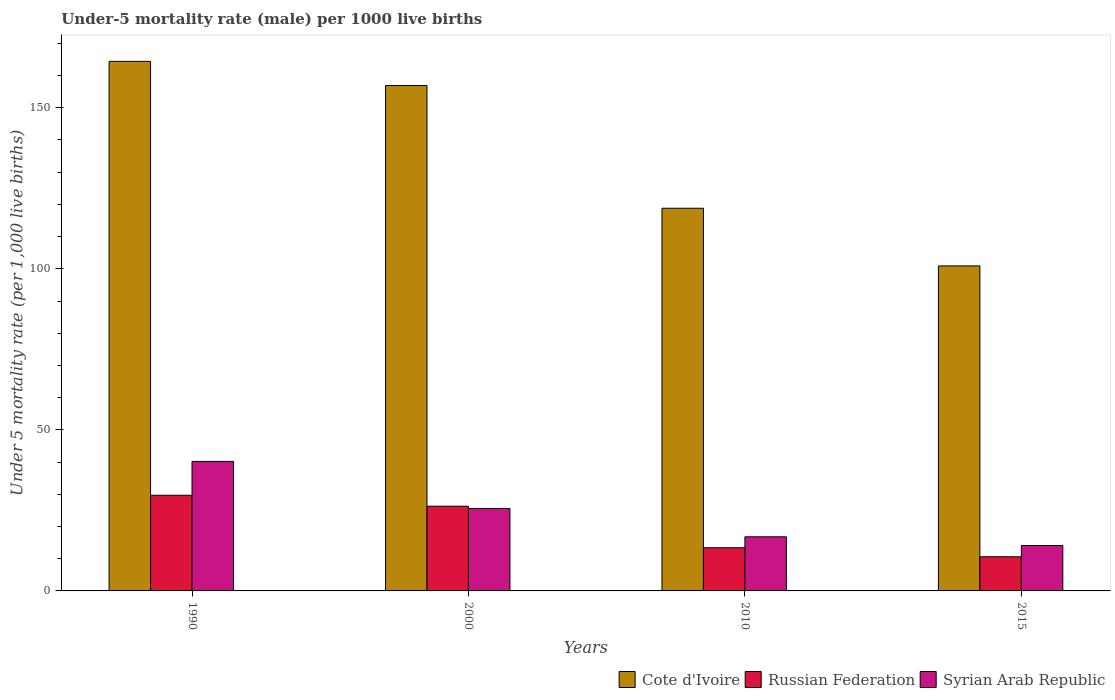How many different coloured bars are there?
Make the answer very short. 3. Are the number of bars per tick equal to the number of legend labels?
Your answer should be compact. Yes. How many bars are there on the 3rd tick from the left?
Keep it short and to the point. 3. What is the label of the 4th group of bars from the left?
Make the answer very short. 2015. In how many cases, is the number of bars for a given year not equal to the number of legend labels?
Offer a terse response. 0. What is the under-five mortality rate in Cote d'Ivoire in 2000?
Your answer should be compact. 156.9. Across all years, what is the maximum under-five mortality rate in Cote d'Ivoire?
Your response must be concise. 164.4. Across all years, what is the minimum under-five mortality rate in Russian Federation?
Your answer should be very brief. 10.6. In which year was the under-five mortality rate in Cote d'Ivoire minimum?
Your answer should be compact. 2015. What is the total under-five mortality rate in Cote d'Ivoire in the graph?
Keep it short and to the point. 541. What is the difference between the under-five mortality rate in Russian Federation in 2000 and that in 2015?
Keep it short and to the point. 15.7. What is the difference between the under-five mortality rate in Cote d'Ivoire in 2010 and the under-five mortality rate in Russian Federation in 2015?
Give a very brief answer. 108.2. What is the average under-five mortality rate in Syrian Arab Republic per year?
Keep it short and to the point. 24.18. In the year 2000, what is the difference between the under-five mortality rate in Russian Federation and under-five mortality rate in Cote d'Ivoire?
Your answer should be compact. -130.6. What is the ratio of the under-five mortality rate in Cote d'Ivoire in 1990 to that in 2015?
Your answer should be very brief. 1.63. Is the difference between the under-five mortality rate in Russian Federation in 2010 and 2015 greater than the difference between the under-five mortality rate in Cote d'Ivoire in 2010 and 2015?
Give a very brief answer. No. What is the difference between the highest and the second highest under-five mortality rate in Russian Federation?
Your answer should be compact. 3.4. In how many years, is the under-five mortality rate in Cote d'Ivoire greater than the average under-five mortality rate in Cote d'Ivoire taken over all years?
Your response must be concise. 2. Is the sum of the under-five mortality rate in Russian Federation in 1990 and 2015 greater than the maximum under-five mortality rate in Syrian Arab Republic across all years?
Your answer should be compact. Yes. What does the 1st bar from the left in 2000 represents?
Your answer should be very brief. Cote d'Ivoire. What does the 2nd bar from the right in 1990 represents?
Ensure brevity in your answer.  Russian Federation. Is it the case that in every year, the sum of the under-five mortality rate in Cote d'Ivoire and under-five mortality rate in Syrian Arab Republic is greater than the under-five mortality rate in Russian Federation?
Your answer should be compact. Yes. How many bars are there?
Provide a short and direct response. 12. Are all the bars in the graph horizontal?
Provide a short and direct response. No. How many years are there in the graph?
Your answer should be compact. 4. What is the difference between two consecutive major ticks on the Y-axis?
Your answer should be very brief. 50. Where does the legend appear in the graph?
Provide a succinct answer. Bottom right. What is the title of the graph?
Offer a very short reply. Under-5 mortality rate (male) per 1000 live births. What is the label or title of the X-axis?
Give a very brief answer. Years. What is the label or title of the Y-axis?
Your answer should be compact. Under 5 mortality rate (per 1,0 live births). What is the Under 5 mortality rate (per 1,000 live births) of Cote d'Ivoire in 1990?
Your response must be concise. 164.4. What is the Under 5 mortality rate (per 1,000 live births) in Russian Federation in 1990?
Provide a short and direct response. 29.7. What is the Under 5 mortality rate (per 1,000 live births) of Syrian Arab Republic in 1990?
Provide a short and direct response. 40.2. What is the Under 5 mortality rate (per 1,000 live births) in Cote d'Ivoire in 2000?
Provide a short and direct response. 156.9. What is the Under 5 mortality rate (per 1,000 live births) in Russian Federation in 2000?
Your response must be concise. 26.3. What is the Under 5 mortality rate (per 1,000 live births) of Syrian Arab Republic in 2000?
Give a very brief answer. 25.6. What is the Under 5 mortality rate (per 1,000 live births) of Cote d'Ivoire in 2010?
Ensure brevity in your answer.  118.8. What is the Under 5 mortality rate (per 1,000 live births) in Syrian Arab Republic in 2010?
Keep it short and to the point. 16.8. What is the Under 5 mortality rate (per 1,000 live births) in Cote d'Ivoire in 2015?
Keep it short and to the point. 100.9. Across all years, what is the maximum Under 5 mortality rate (per 1,000 live births) in Cote d'Ivoire?
Your response must be concise. 164.4. Across all years, what is the maximum Under 5 mortality rate (per 1,000 live births) in Russian Federation?
Ensure brevity in your answer.  29.7. Across all years, what is the maximum Under 5 mortality rate (per 1,000 live births) in Syrian Arab Republic?
Keep it short and to the point. 40.2. Across all years, what is the minimum Under 5 mortality rate (per 1,000 live births) of Cote d'Ivoire?
Keep it short and to the point. 100.9. Across all years, what is the minimum Under 5 mortality rate (per 1,000 live births) of Russian Federation?
Your answer should be compact. 10.6. Across all years, what is the minimum Under 5 mortality rate (per 1,000 live births) of Syrian Arab Republic?
Offer a very short reply. 14.1. What is the total Under 5 mortality rate (per 1,000 live births) in Cote d'Ivoire in the graph?
Provide a succinct answer. 541. What is the total Under 5 mortality rate (per 1,000 live births) in Syrian Arab Republic in the graph?
Give a very brief answer. 96.7. What is the difference between the Under 5 mortality rate (per 1,000 live births) in Russian Federation in 1990 and that in 2000?
Your answer should be compact. 3.4. What is the difference between the Under 5 mortality rate (per 1,000 live births) of Cote d'Ivoire in 1990 and that in 2010?
Provide a short and direct response. 45.6. What is the difference between the Under 5 mortality rate (per 1,000 live births) in Russian Federation in 1990 and that in 2010?
Ensure brevity in your answer.  16.3. What is the difference between the Under 5 mortality rate (per 1,000 live births) in Syrian Arab Republic in 1990 and that in 2010?
Make the answer very short. 23.4. What is the difference between the Under 5 mortality rate (per 1,000 live births) in Cote d'Ivoire in 1990 and that in 2015?
Offer a very short reply. 63.5. What is the difference between the Under 5 mortality rate (per 1,000 live births) of Syrian Arab Republic in 1990 and that in 2015?
Your answer should be very brief. 26.1. What is the difference between the Under 5 mortality rate (per 1,000 live births) of Cote d'Ivoire in 2000 and that in 2010?
Offer a very short reply. 38.1. What is the difference between the Under 5 mortality rate (per 1,000 live births) of Cote d'Ivoire in 2000 and that in 2015?
Your answer should be compact. 56. What is the difference between the Under 5 mortality rate (per 1,000 live births) of Russian Federation in 2000 and that in 2015?
Make the answer very short. 15.7. What is the difference between the Under 5 mortality rate (per 1,000 live births) of Cote d'Ivoire in 2010 and that in 2015?
Provide a succinct answer. 17.9. What is the difference between the Under 5 mortality rate (per 1,000 live births) in Russian Federation in 2010 and that in 2015?
Ensure brevity in your answer.  2.8. What is the difference between the Under 5 mortality rate (per 1,000 live births) of Syrian Arab Republic in 2010 and that in 2015?
Your answer should be very brief. 2.7. What is the difference between the Under 5 mortality rate (per 1,000 live births) of Cote d'Ivoire in 1990 and the Under 5 mortality rate (per 1,000 live births) of Russian Federation in 2000?
Your response must be concise. 138.1. What is the difference between the Under 5 mortality rate (per 1,000 live births) of Cote d'Ivoire in 1990 and the Under 5 mortality rate (per 1,000 live births) of Syrian Arab Republic in 2000?
Ensure brevity in your answer.  138.8. What is the difference between the Under 5 mortality rate (per 1,000 live births) of Russian Federation in 1990 and the Under 5 mortality rate (per 1,000 live births) of Syrian Arab Republic in 2000?
Offer a terse response. 4.1. What is the difference between the Under 5 mortality rate (per 1,000 live births) of Cote d'Ivoire in 1990 and the Under 5 mortality rate (per 1,000 live births) of Russian Federation in 2010?
Keep it short and to the point. 151. What is the difference between the Under 5 mortality rate (per 1,000 live births) in Cote d'Ivoire in 1990 and the Under 5 mortality rate (per 1,000 live births) in Syrian Arab Republic in 2010?
Provide a succinct answer. 147.6. What is the difference between the Under 5 mortality rate (per 1,000 live births) in Cote d'Ivoire in 1990 and the Under 5 mortality rate (per 1,000 live births) in Russian Federation in 2015?
Offer a terse response. 153.8. What is the difference between the Under 5 mortality rate (per 1,000 live births) of Cote d'Ivoire in 1990 and the Under 5 mortality rate (per 1,000 live births) of Syrian Arab Republic in 2015?
Your response must be concise. 150.3. What is the difference between the Under 5 mortality rate (per 1,000 live births) of Cote d'Ivoire in 2000 and the Under 5 mortality rate (per 1,000 live births) of Russian Federation in 2010?
Your response must be concise. 143.5. What is the difference between the Under 5 mortality rate (per 1,000 live births) in Cote d'Ivoire in 2000 and the Under 5 mortality rate (per 1,000 live births) in Syrian Arab Republic in 2010?
Keep it short and to the point. 140.1. What is the difference between the Under 5 mortality rate (per 1,000 live births) of Russian Federation in 2000 and the Under 5 mortality rate (per 1,000 live births) of Syrian Arab Republic in 2010?
Offer a very short reply. 9.5. What is the difference between the Under 5 mortality rate (per 1,000 live births) in Cote d'Ivoire in 2000 and the Under 5 mortality rate (per 1,000 live births) in Russian Federation in 2015?
Offer a very short reply. 146.3. What is the difference between the Under 5 mortality rate (per 1,000 live births) in Cote d'Ivoire in 2000 and the Under 5 mortality rate (per 1,000 live births) in Syrian Arab Republic in 2015?
Make the answer very short. 142.8. What is the difference between the Under 5 mortality rate (per 1,000 live births) of Russian Federation in 2000 and the Under 5 mortality rate (per 1,000 live births) of Syrian Arab Republic in 2015?
Offer a very short reply. 12.2. What is the difference between the Under 5 mortality rate (per 1,000 live births) of Cote d'Ivoire in 2010 and the Under 5 mortality rate (per 1,000 live births) of Russian Federation in 2015?
Offer a terse response. 108.2. What is the difference between the Under 5 mortality rate (per 1,000 live births) of Cote d'Ivoire in 2010 and the Under 5 mortality rate (per 1,000 live births) of Syrian Arab Republic in 2015?
Your response must be concise. 104.7. What is the average Under 5 mortality rate (per 1,000 live births) in Cote d'Ivoire per year?
Offer a terse response. 135.25. What is the average Under 5 mortality rate (per 1,000 live births) of Syrian Arab Republic per year?
Your answer should be compact. 24.18. In the year 1990, what is the difference between the Under 5 mortality rate (per 1,000 live births) in Cote d'Ivoire and Under 5 mortality rate (per 1,000 live births) in Russian Federation?
Your answer should be compact. 134.7. In the year 1990, what is the difference between the Under 5 mortality rate (per 1,000 live births) in Cote d'Ivoire and Under 5 mortality rate (per 1,000 live births) in Syrian Arab Republic?
Give a very brief answer. 124.2. In the year 2000, what is the difference between the Under 5 mortality rate (per 1,000 live births) in Cote d'Ivoire and Under 5 mortality rate (per 1,000 live births) in Russian Federation?
Ensure brevity in your answer.  130.6. In the year 2000, what is the difference between the Under 5 mortality rate (per 1,000 live births) of Cote d'Ivoire and Under 5 mortality rate (per 1,000 live births) of Syrian Arab Republic?
Your answer should be compact. 131.3. In the year 2010, what is the difference between the Under 5 mortality rate (per 1,000 live births) of Cote d'Ivoire and Under 5 mortality rate (per 1,000 live births) of Russian Federation?
Offer a very short reply. 105.4. In the year 2010, what is the difference between the Under 5 mortality rate (per 1,000 live births) of Cote d'Ivoire and Under 5 mortality rate (per 1,000 live births) of Syrian Arab Republic?
Give a very brief answer. 102. In the year 2015, what is the difference between the Under 5 mortality rate (per 1,000 live births) of Cote d'Ivoire and Under 5 mortality rate (per 1,000 live births) of Russian Federation?
Provide a succinct answer. 90.3. In the year 2015, what is the difference between the Under 5 mortality rate (per 1,000 live births) of Cote d'Ivoire and Under 5 mortality rate (per 1,000 live births) of Syrian Arab Republic?
Offer a terse response. 86.8. In the year 2015, what is the difference between the Under 5 mortality rate (per 1,000 live births) in Russian Federation and Under 5 mortality rate (per 1,000 live births) in Syrian Arab Republic?
Your answer should be compact. -3.5. What is the ratio of the Under 5 mortality rate (per 1,000 live births) of Cote d'Ivoire in 1990 to that in 2000?
Make the answer very short. 1.05. What is the ratio of the Under 5 mortality rate (per 1,000 live births) in Russian Federation in 1990 to that in 2000?
Ensure brevity in your answer.  1.13. What is the ratio of the Under 5 mortality rate (per 1,000 live births) of Syrian Arab Republic in 1990 to that in 2000?
Your answer should be very brief. 1.57. What is the ratio of the Under 5 mortality rate (per 1,000 live births) of Cote d'Ivoire in 1990 to that in 2010?
Your response must be concise. 1.38. What is the ratio of the Under 5 mortality rate (per 1,000 live births) of Russian Federation in 1990 to that in 2010?
Your answer should be compact. 2.22. What is the ratio of the Under 5 mortality rate (per 1,000 live births) of Syrian Arab Republic in 1990 to that in 2010?
Your answer should be compact. 2.39. What is the ratio of the Under 5 mortality rate (per 1,000 live births) of Cote d'Ivoire in 1990 to that in 2015?
Make the answer very short. 1.63. What is the ratio of the Under 5 mortality rate (per 1,000 live births) in Russian Federation in 1990 to that in 2015?
Your response must be concise. 2.8. What is the ratio of the Under 5 mortality rate (per 1,000 live births) in Syrian Arab Republic in 1990 to that in 2015?
Your answer should be very brief. 2.85. What is the ratio of the Under 5 mortality rate (per 1,000 live births) in Cote d'Ivoire in 2000 to that in 2010?
Give a very brief answer. 1.32. What is the ratio of the Under 5 mortality rate (per 1,000 live births) in Russian Federation in 2000 to that in 2010?
Your response must be concise. 1.96. What is the ratio of the Under 5 mortality rate (per 1,000 live births) in Syrian Arab Republic in 2000 to that in 2010?
Offer a terse response. 1.52. What is the ratio of the Under 5 mortality rate (per 1,000 live births) in Cote d'Ivoire in 2000 to that in 2015?
Your response must be concise. 1.55. What is the ratio of the Under 5 mortality rate (per 1,000 live births) in Russian Federation in 2000 to that in 2015?
Offer a terse response. 2.48. What is the ratio of the Under 5 mortality rate (per 1,000 live births) in Syrian Arab Republic in 2000 to that in 2015?
Offer a terse response. 1.82. What is the ratio of the Under 5 mortality rate (per 1,000 live births) of Cote d'Ivoire in 2010 to that in 2015?
Keep it short and to the point. 1.18. What is the ratio of the Under 5 mortality rate (per 1,000 live births) of Russian Federation in 2010 to that in 2015?
Your answer should be very brief. 1.26. What is the ratio of the Under 5 mortality rate (per 1,000 live births) of Syrian Arab Republic in 2010 to that in 2015?
Provide a succinct answer. 1.19. What is the difference between the highest and the second highest Under 5 mortality rate (per 1,000 live births) of Cote d'Ivoire?
Offer a very short reply. 7.5. What is the difference between the highest and the second highest Under 5 mortality rate (per 1,000 live births) in Russian Federation?
Offer a terse response. 3.4. What is the difference between the highest and the lowest Under 5 mortality rate (per 1,000 live births) in Cote d'Ivoire?
Provide a short and direct response. 63.5. What is the difference between the highest and the lowest Under 5 mortality rate (per 1,000 live births) of Russian Federation?
Give a very brief answer. 19.1. What is the difference between the highest and the lowest Under 5 mortality rate (per 1,000 live births) of Syrian Arab Republic?
Make the answer very short. 26.1. 